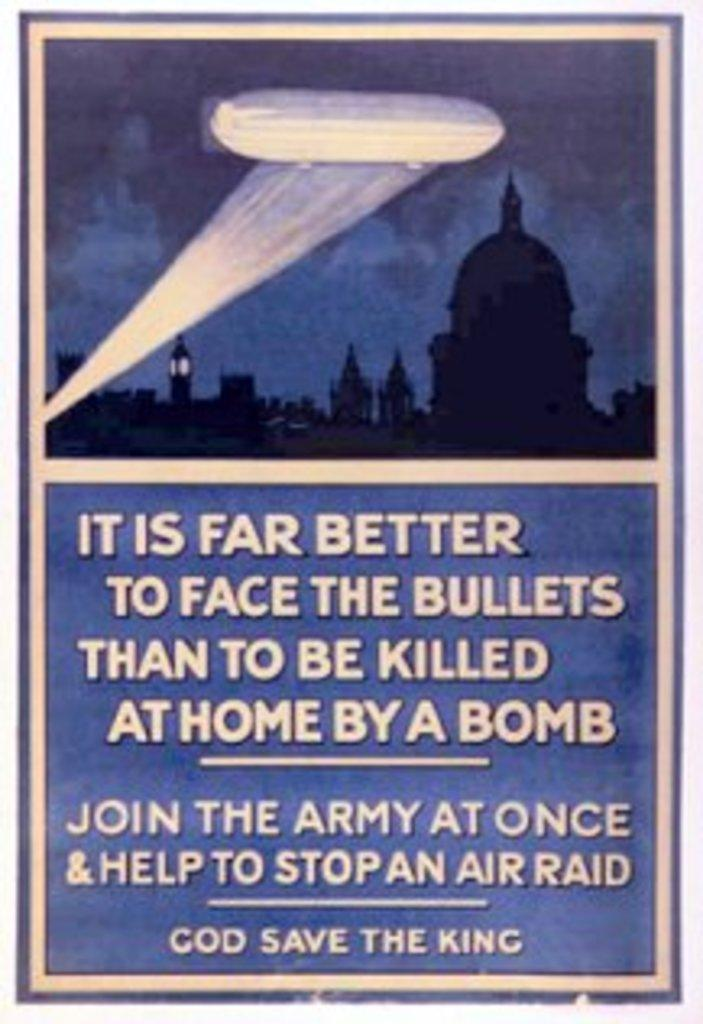<image>
Create a compact narrative representing the image presented. A poster that states It is far better to face the bullets than to be killed at home by a bomb. 